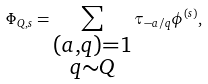<formula> <loc_0><loc_0><loc_500><loc_500>\Phi _ { Q , s } = \sum _ { \substack { ( a , q ) = 1 \\ q \sim Q } } \tau _ { - a / q } \phi ^ { ( s ) } ,</formula> 